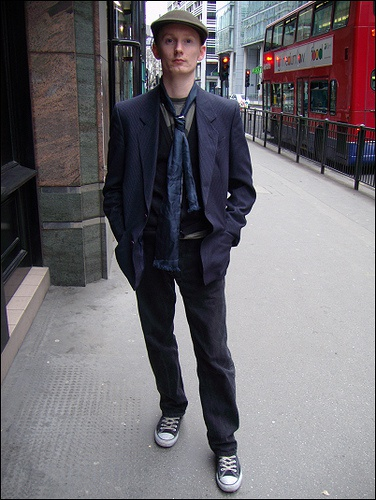Describe the objects in this image and their specific colors. I can see people in black, navy, gray, and darkgray tones, bus in black, maroon, gray, and brown tones, traffic light in black, maroon, and purple tones, traffic light in black, navy, lightgray, and gray tones, and traffic light in black, gray, darkgray, and lightgray tones in this image. 